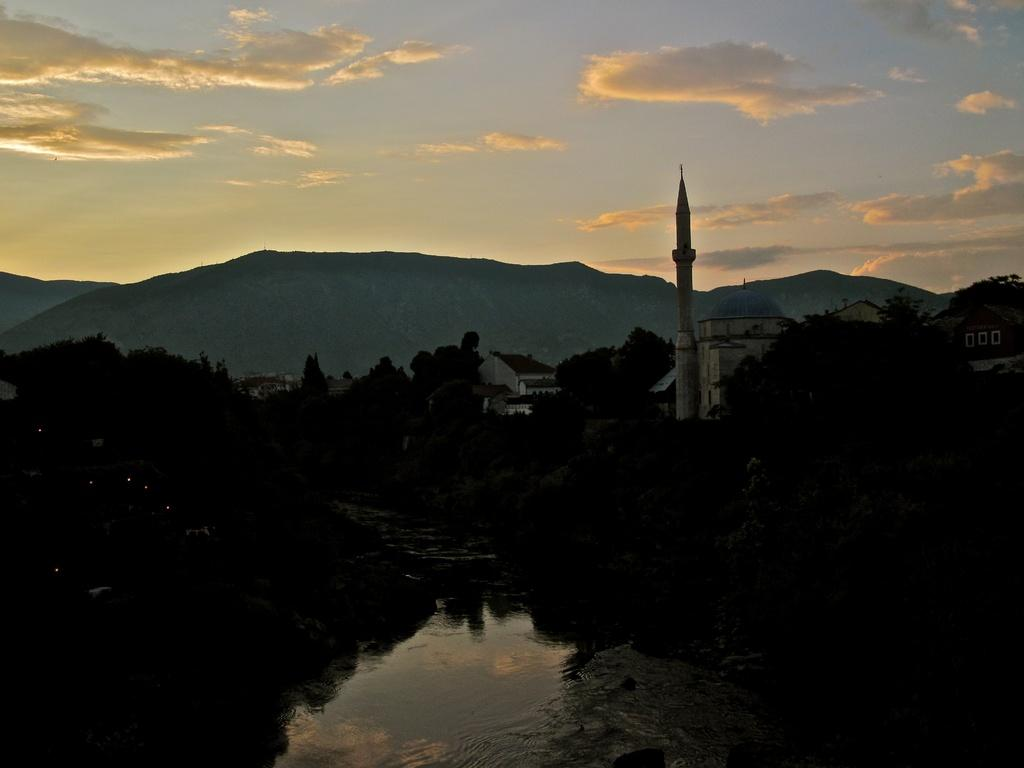What can be seen in the image that is not solid? Water is visible in the image, which is not solid. Where are the trees located in the image? There are trees on both the left and right sides of the image. What type of structures can be seen in the image? There are buildings in the image. What type of natural landform is visible in the image? Hills are visible in the image. What is visible in the sky in the image? The sky is visible in the image, and clouds are present. What type of cap can be seen on the crow in the image? There is no cap or crow present in the image. How is the string used in the image? There is no string present in the image. 